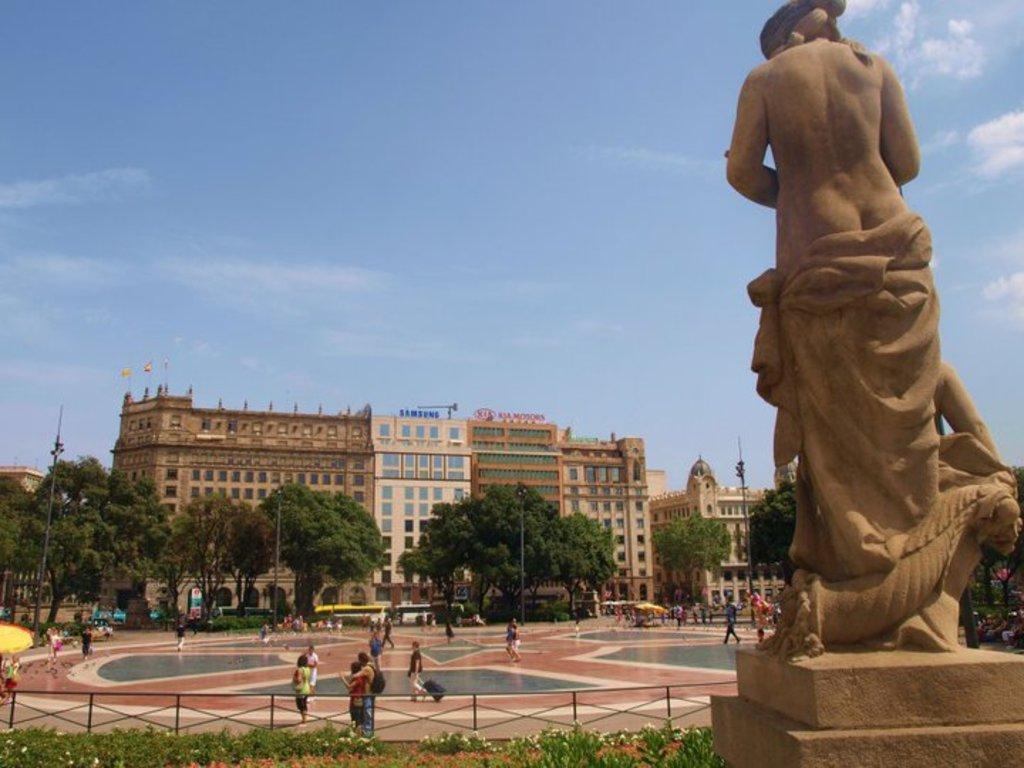Please provide a concise description of this image. In the foreground of the picture there are plants, flowers, railing and a sculpture. In the center of the picture there are trees, people, vehicles and buildings. Sky is sunny. 